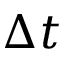Convert formula to latex. <formula><loc_0><loc_0><loc_500><loc_500>\Delta t</formula> 